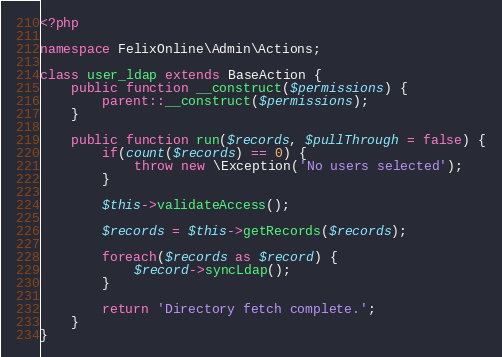<code> <loc_0><loc_0><loc_500><loc_500><_PHP_><?php

namespace FelixOnline\Admin\Actions;

class user_ldap extends BaseAction {
	public function __construct($permissions) {
		parent::__construct($permissions);
	}

	public function run($records, $pullThrough = false) {
		if(count($records) == 0) {
			throw new \Exception('No users selected');
		}

		$this->validateAccess();

		$records = $this->getRecords($records);

		foreach($records as $record) {
			$record->syncLdap();
		}

		return 'Directory fetch complete.';
	}
}</code> 